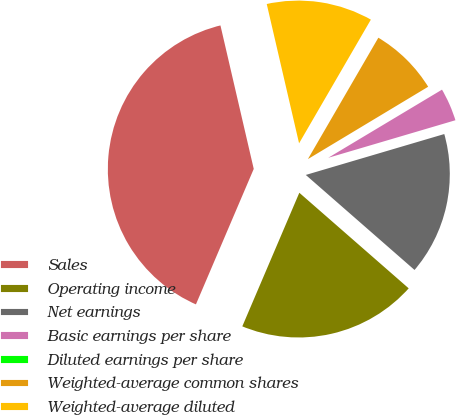<chart> <loc_0><loc_0><loc_500><loc_500><pie_chart><fcel>Sales<fcel>Operating income<fcel>Net earnings<fcel>Basic earnings per share<fcel>Diluted earnings per share<fcel>Weighted-average common shares<fcel>Weighted-average diluted<nl><fcel>39.95%<fcel>19.99%<fcel>16.0%<fcel>4.02%<fcel>0.03%<fcel>8.01%<fcel>12.0%<nl></chart> 